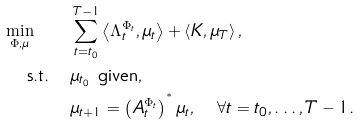<formula> <loc_0><loc_0><loc_500><loc_500>\min _ { \Phi , \mu } \quad & \sum _ { t = t _ { 0 } } ^ { T - 1 } \left \langle \Lambda _ { t } ^ { \Phi _ { t } } , \mu _ { t } \right \rangle + \left \langle K , \mu _ { T } \right \rangle , \\ \text {s.t.} \quad & \mu _ { t _ { 0 } } \text { given} , \\ & \mu _ { t + 1 } = \left ( A _ { t } ^ { \Phi _ { t } } \right ) ^ { ^ { * } } \mu _ { t } , \quad \forall t = t _ { 0 } , \dots , T - 1 .</formula> 